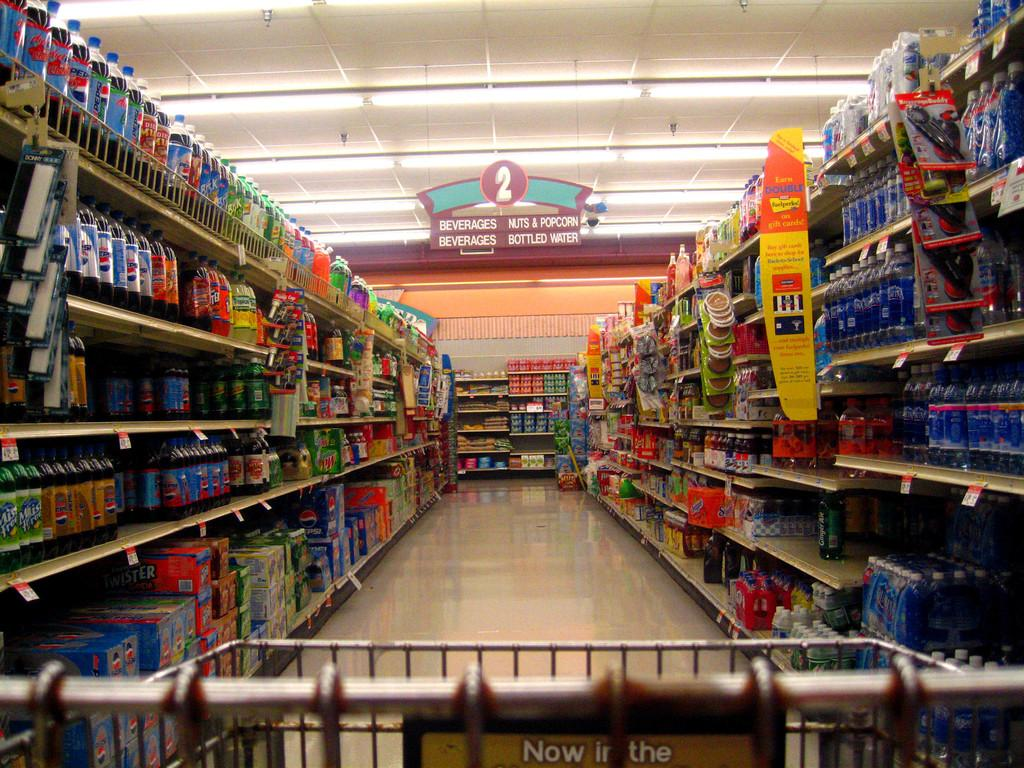<image>
Offer a succinct explanation of the picture presented. A supermarket aisle stocks Beverages, Nuts & Popcorn, and Bottled Water. 